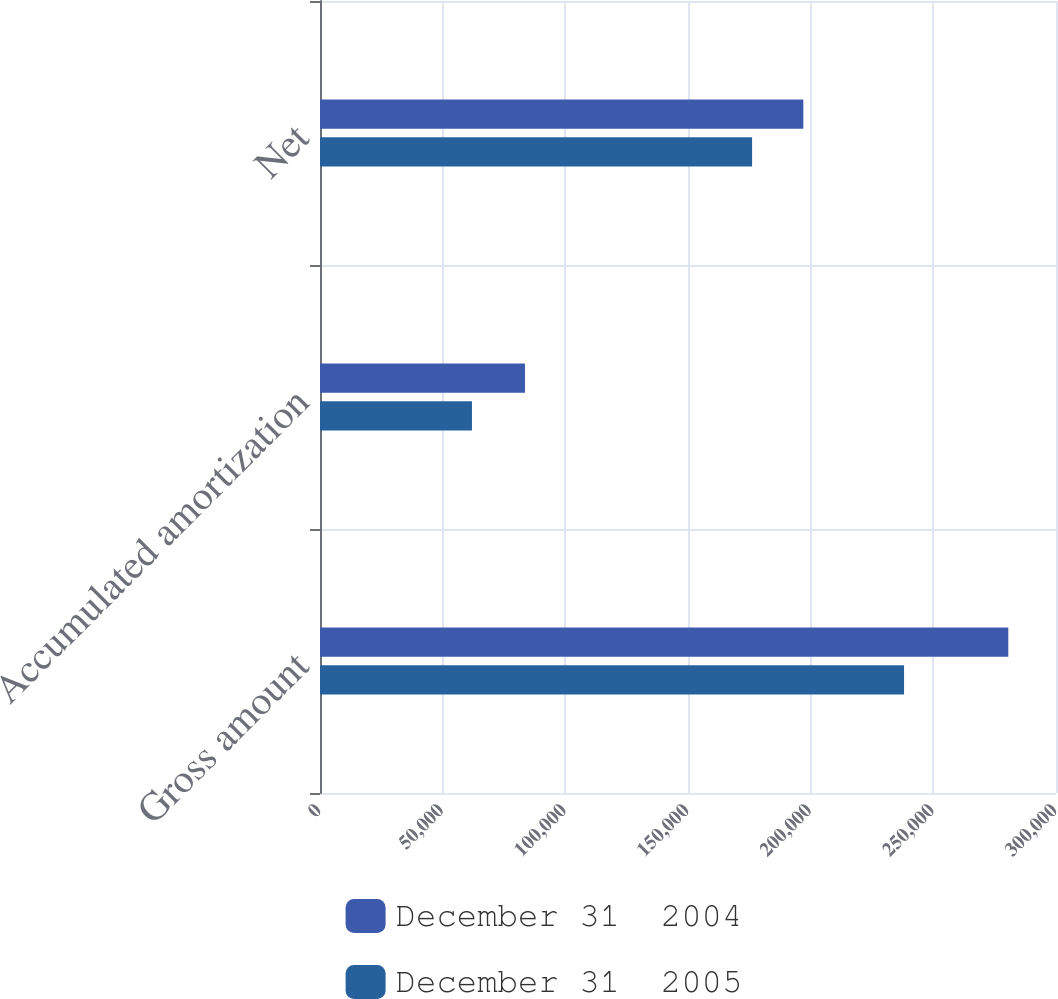<chart> <loc_0><loc_0><loc_500><loc_500><stacked_bar_chart><ecel><fcel>Gross amount<fcel>Accumulated amortization<fcel>Net<nl><fcel>December 31  2004<fcel>280561<fcel>83547<fcel>197014<nl><fcel>December 31  2005<fcel>238064<fcel>61942<fcel>176122<nl></chart> 